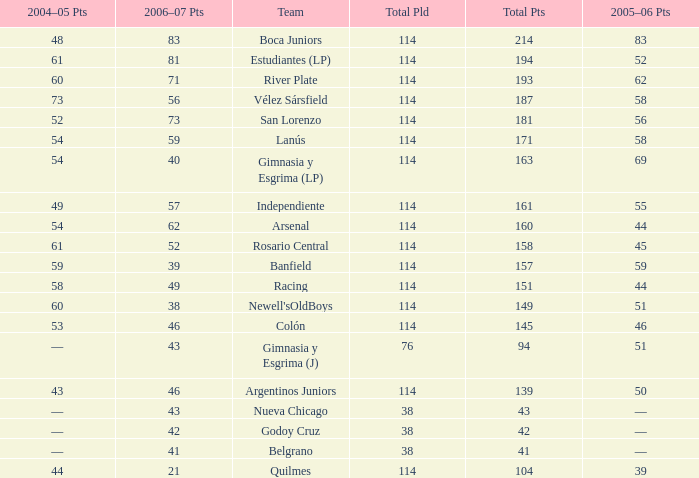What is the total number of points for a total pld less than 38? 0.0. 